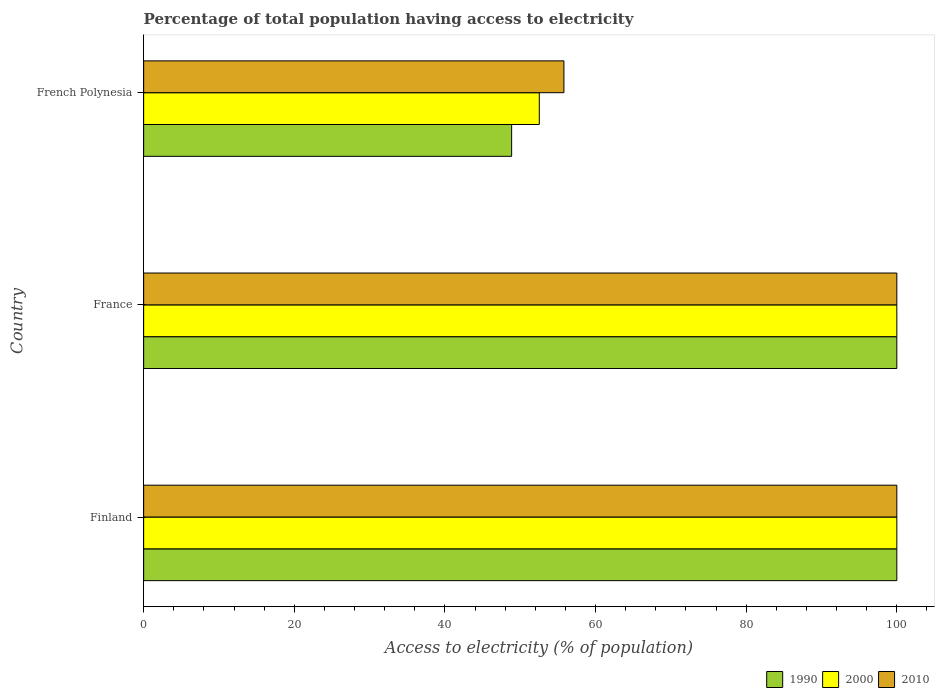How many groups of bars are there?
Ensure brevity in your answer.  3. Are the number of bars per tick equal to the number of legend labels?
Offer a terse response. Yes. Are the number of bars on each tick of the Y-axis equal?
Offer a terse response. Yes. What is the label of the 2nd group of bars from the top?
Your answer should be very brief. France. In how many cases, is the number of bars for a given country not equal to the number of legend labels?
Keep it short and to the point. 0. Across all countries, what is the minimum percentage of population that have access to electricity in 2000?
Offer a very short reply. 52.53. In which country was the percentage of population that have access to electricity in 2000 maximum?
Ensure brevity in your answer.  Finland. In which country was the percentage of population that have access to electricity in 1990 minimum?
Your answer should be compact. French Polynesia. What is the total percentage of population that have access to electricity in 2000 in the graph?
Your answer should be compact. 252.53. What is the difference between the percentage of population that have access to electricity in 1990 in Finland and that in French Polynesia?
Ensure brevity in your answer.  51.14. What is the difference between the percentage of population that have access to electricity in 1990 in French Polynesia and the percentage of population that have access to electricity in 2010 in Finland?
Your response must be concise. -51.14. What is the average percentage of population that have access to electricity in 2000 per country?
Give a very brief answer. 84.18. What is the difference between the percentage of population that have access to electricity in 2000 and percentage of population that have access to electricity in 2010 in Finland?
Offer a very short reply. 0. What is the ratio of the percentage of population that have access to electricity in 1990 in Finland to that in French Polynesia?
Offer a terse response. 2.05. Is the percentage of population that have access to electricity in 2010 in France less than that in French Polynesia?
Offer a terse response. No. What is the difference between the highest and the second highest percentage of population that have access to electricity in 2010?
Provide a short and direct response. 0. What is the difference between the highest and the lowest percentage of population that have access to electricity in 2000?
Your answer should be compact. 47.47. Is the sum of the percentage of population that have access to electricity in 2010 in Finland and France greater than the maximum percentage of population that have access to electricity in 1990 across all countries?
Provide a succinct answer. Yes. What does the 3rd bar from the top in Finland represents?
Give a very brief answer. 1990. What does the 1st bar from the bottom in France represents?
Your response must be concise. 1990. How many bars are there?
Your response must be concise. 9. What is the difference between two consecutive major ticks on the X-axis?
Provide a short and direct response. 20. Are the values on the major ticks of X-axis written in scientific E-notation?
Your answer should be compact. No. Does the graph contain any zero values?
Keep it short and to the point. No. Does the graph contain grids?
Offer a very short reply. No. Where does the legend appear in the graph?
Ensure brevity in your answer.  Bottom right. How are the legend labels stacked?
Offer a very short reply. Horizontal. What is the title of the graph?
Provide a succinct answer. Percentage of total population having access to electricity. What is the label or title of the X-axis?
Provide a short and direct response. Access to electricity (% of population). What is the Access to electricity (% of population) of 1990 in Finland?
Your answer should be compact. 100. What is the Access to electricity (% of population) in 2010 in Finland?
Ensure brevity in your answer.  100. What is the Access to electricity (% of population) of 1990 in France?
Provide a short and direct response. 100. What is the Access to electricity (% of population) of 2000 in France?
Your response must be concise. 100. What is the Access to electricity (% of population) of 2010 in France?
Make the answer very short. 100. What is the Access to electricity (% of population) in 1990 in French Polynesia?
Make the answer very short. 48.86. What is the Access to electricity (% of population) of 2000 in French Polynesia?
Ensure brevity in your answer.  52.53. What is the Access to electricity (% of population) in 2010 in French Polynesia?
Ensure brevity in your answer.  55.8. Across all countries, what is the maximum Access to electricity (% of population) of 1990?
Your answer should be compact. 100. Across all countries, what is the minimum Access to electricity (% of population) of 1990?
Ensure brevity in your answer.  48.86. Across all countries, what is the minimum Access to electricity (% of population) of 2000?
Keep it short and to the point. 52.53. Across all countries, what is the minimum Access to electricity (% of population) in 2010?
Provide a short and direct response. 55.8. What is the total Access to electricity (% of population) of 1990 in the graph?
Make the answer very short. 248.86. What is the total Access to electricity (% of population) in 2000 in the graph?
Make the answer very short. 252.53. What is the total Access to electricity (% of population) of 2010 in the graph?
Offer a very short reply. 255.8. What is the difference between the Access to electricity (% of population) in 1990 in Finland and that in France?
Offer a terse response. 0. What is the difference between the Access to electricity (% of population) of 2000 in Finland and that in France?
Provide a succinct answer. 0. What is the difference between the Access to electricity (% of population) of 2010 in Finland and that in France?
Ensure brevity in your answer.  0. What is the difference between the Access to electricity (% of population) of 1990 in Finland and that in French Polynesia?
Ensure brevity in your answer.  51.14. What is the difference between the Access to electricity (% of population) of 2000 in Finland and that in French Polynesia?
Offer a very short reply. 47.47. What is the difference between the Access to electricity (% of population) of 2010 in Finland and that in French Polynesia?
Your answer should be compact. 44.2. What is the difference between the Access to electricity (% of population) of 1990 in France and that in French Polynesia?
Ensure brevity in your answer.  51.14. What is the difference between the Access to electricity (% of population) of 2000 in France and that in French Polynesia?
Your answer should be very brief. 47.47. What is the difference between the Access to electricity (% of population) of 2010 in France and that in French Polynesia?
Offer a very short reply. 44.2. What is the difference between the Access to electricity (% of population) of 1990 in Finland and the Access to electricity (% of population) of 2000 in French Polynesia?
Give a very brief answer. 47.47. What is the difference between the Access to electricity (% of population) of 1990 in Finland and the Access to electricity (% of population) of 2010 in French Polynesia?
Ensure brevity in your answer.  44.2. What is the difference between the Access to electricity (% of population) of 2000 in Finland and the Access to electricity (% of population) of 2010 in French Polynesia?
Your answer should be very brief. 44.2. What is the difference between the Access to electricity (% of population) in 1990 in France and the Access to electricity (% of population) in 2000 in French Polynesia?
Make the answer very short. 47.47. What is the difference between the Access to electricity (% of population) of 1990 in France and the Access to electricity (% of population) of 2010 in French Polynesia?
Offer a terse response. 44.2. What is the difference between the Access to electricity (% of population) of 2000 in France and the Access to electricity (% of population) of 2010 in French Polynesia?
Your answer should be very brief. 44.2. What is the average Access to electricity (% of population) of 1990 per country?
Make the answer very short. 82.95. What is the average Access to electricity (% of population) in 2000 per country?
Offer a very short reply. 84.18. What is the average Access to electricity (% of population) of 2010 per country?
Offer a terse response. 85.27. What is the difference between the Access to electricity (% of population) of 1990 and Access to electricity (% of population) of 2010 in Finland?
Provide a short and direct response. 0. What is the difference between the Access to electricity (% of population) in 1990 and Access to electricity (% of population) in 2000 in France?
Give a very brief answer. 0. What is the difference between the Access to electricity (% of population) in 2000 and Access to electricity (% of population) in 2010 in France?
Provide a short and direct response. 0. What is the difference between the Access to electricity (% of population) of 1990 and Access to electricity (% of population) of 2000 in French Polynesia?
Your answer should be very brief. -3.67. What is the difference between the Access to electricity (% of population) in 1990 and Access to electricity (% of population) in 2010 in French Polynesia?
Give a very brief answer. -6.94. What is the difference between the Access to electricity (% of population) in 2000 and Access to electricity (% of population) in 2010 in French Polynesia?
Offer a terse response. -3.27. What is the ratio of the Access to electricity (% of population) in 2010 in Finland to that in France?
Provide a short and direct response. 1. What is the ratio of the Access to electricity (% of population) of 1990 in Finland to that in French Polynesia?
Your answer should be very brief. 2.05. What is the ratio of the Access to electricity (% of population) in 2000 in Finland to that in French Polynesia?
Offer a very short reply. 1.9. What is the ratio of the Access to electricity (% of population) of 2010 in Finland to that in French Polynesia?
Ensure brevity in your answer.  1.79. What is the ratio of the Access to electricity (% of population) of 1990 in France to that in French Polynesia?
Offer a terse response. 2.05. What is the ratio of the Access to electricity (% of population) in 2000 in France to that in French Polynesia?
Keep it short and to the point. 1.9. What is the ratio of the Access to electricity (% of population) in 2010 in France to that in French Polynesia?
Make the answer very short. 1.79. What is the difference between the highest and the second highest Access to electricity (% of population) in 1990?
Provide a short and direct response. 0. What is the difference between the highest and the second highest Access to electricity (% of population) of 2010?
Your response must be concise. 0. What is the difference between the highest and the lowest Access to electricity (% of population) of 1990?
Your answer should be very brief. 51.14. What is the difference between the highest and the lowest Access to electricity (% of population) of 2000?
Your answer should be very brief. 47.47. What is the difference between the highest and the lowest Access to electricity (% of population) in 2010?
Make the answer very short. 44.2. 